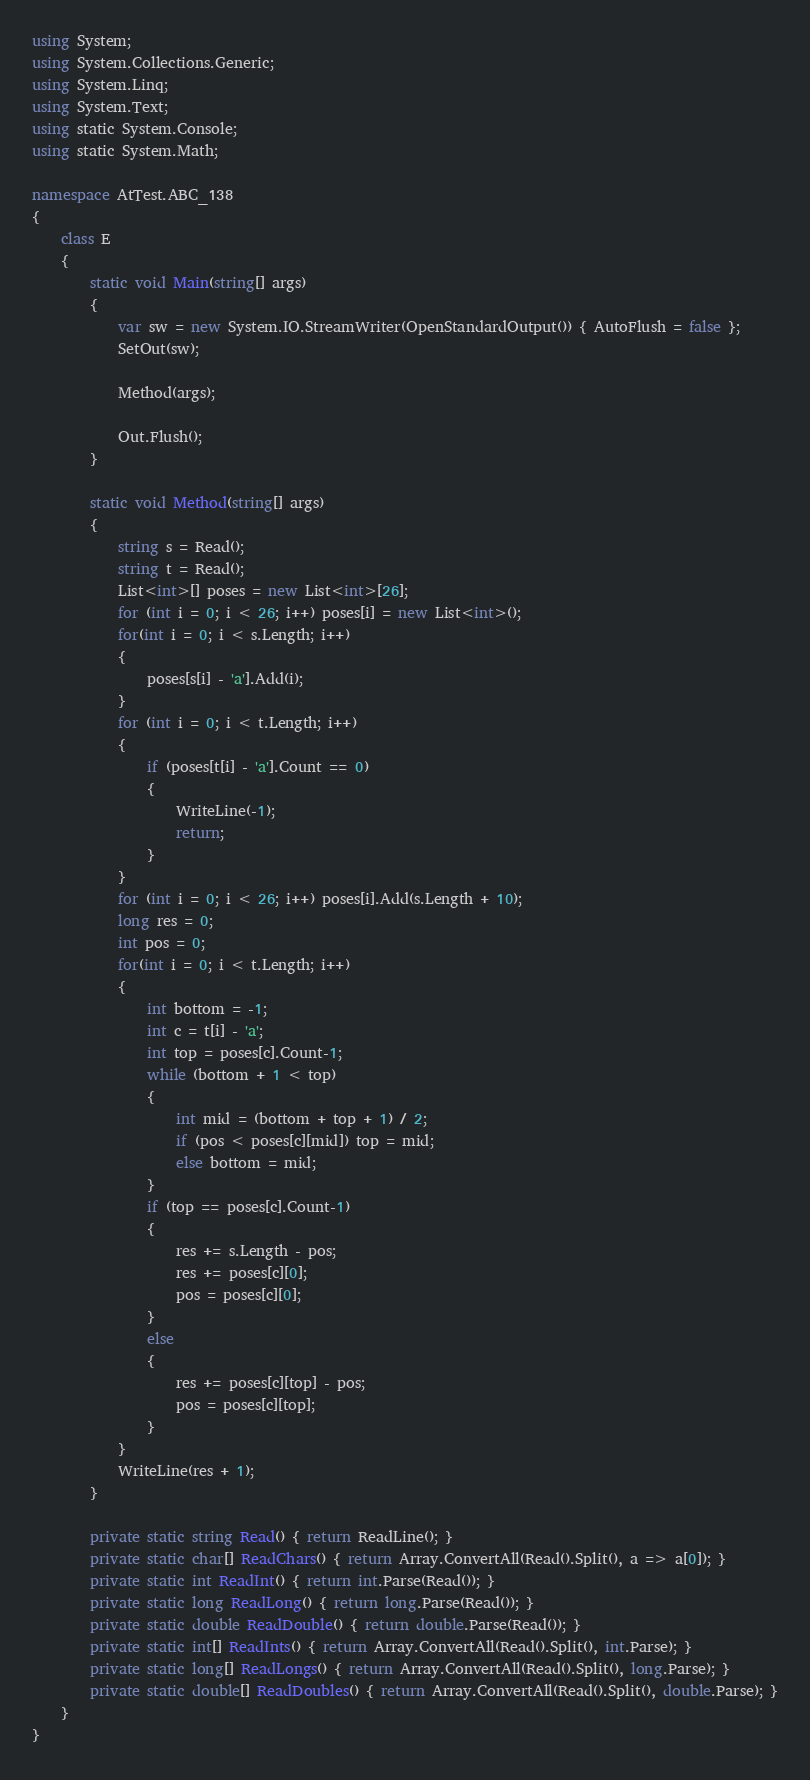Convert code to text. <code><loc_0><loc_0><loc_500><loc_500><_C#_>using System;
using System.Collections.Generic;
using System.Linq;
using System.Text;
using static System.Console;
using static System.Math;

namespace AtTest.ABC_138
{
    class E
    {
        static void Main(string[] args)
        {
            var sw = new System.IO.StreamWriter(OpenStandardOutput()) { AutoFlush = false };
            SetOut(sw);

            Method(args);

            Out.Flush();
        }

        static void Method(string[] args)
        {
            string s = Read();
            string t = Read();
            List<int>[] poses = new List<int>[26];
            for (int i = 0; i < 26; i++) poses[i] = new List<int>();
            for(int i = 0; i < s.Length; i++)
            {
                poses[s[i] - 'a'].Add(i);
            }
            for (int i = 0; i < t.Length; i++)
            {
                if (poses[t[i] - 'a'].Count == 0)
                {
                    WriteLine(-1);
                    return;
                }
            }
            for (int i = 0; i < 26; i++) poses[i].Add(s.Length + 10);
            long res = 0;
            int pos = 0;
            for(int i = 0; i < t.Length; i++)
            {
                int bottom = -1;
                int c = t[i] - 'a';
                int top = poses[c].Count-1;
                while (bottom + 1 < top)
                {
                    int mid = (bottom + top + 1) / 2;
                    if (pos < poses[c][mid]) top = mid;
                    else bottom = mid;
                }
                if (top == poses[c].Count-1)
                {
                    res += s.Length - pos;
                    res += poses[c][0];
                    pos = poses[c][0];
                }
                else
                {
                    res += poses[c][top] - pos;
                    pos = poses[c][top];
                }
            }
            WriteLine(res + 1);
        }

        private static string Read() { return ReadLine(); }
        private static char[] ReadChars() { return Array.ConvertAll(Read().Split(), a => a[0]); }
        private static int ReadInt() { return int.Parse(Read()); }
        private static long ReadLong() { return long.Parse(Read()); }
        private static double ReadDouble() { return double.Parse(Read()); }
        private static int[] ReadInts() { return Array.ConvertAll(Read().Split(), int.Parse); }
        private static long[] ReadLongs() { return Array.ConvertAll(Read().Split(), long.Parse); }
        private static double[] ReadDoubles() { return Array.ConvertAll(Read().Split(), double.Parse); }
    }
}
</code> 